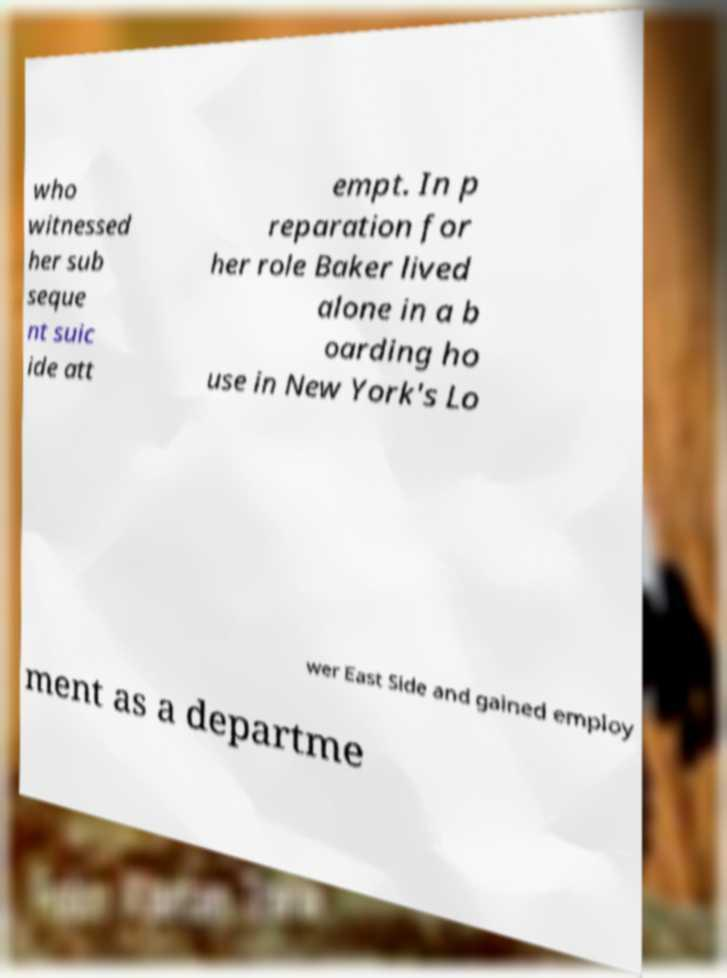I need the written content from this picture converted into text. Can you do that? who witnessed her sub seque nt suic ide att empt. In p reparation for her role Baker lived alone in a b oarding ho use in New York's Lo wer East Side and gained employ ment as a departme 